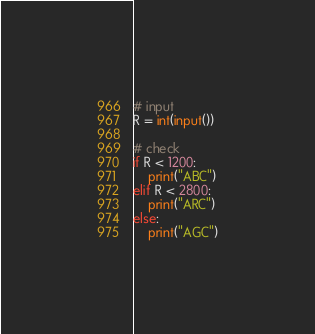Convert code to text. <code><loc_0><loc_0><loc_500><loc_500><_Python_># input
R = int(input())

# check
if R < 1200:
    print("ABC")
elif R < 2800:
    print("ARC")
else:
    print("AGC")
</code> 